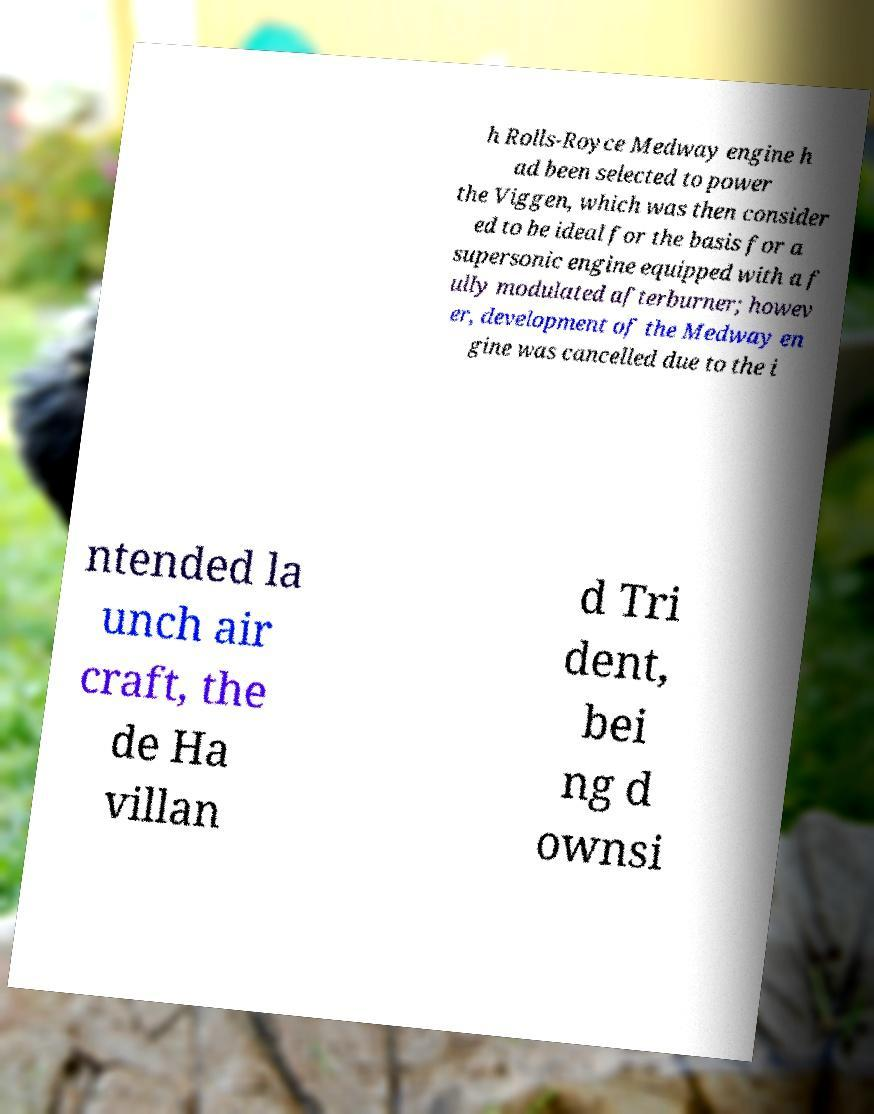Could you assist in decoding the text presented in this image and type it out clearly? h Rolls-Royce Medway engine h ad been selected to power the Viggen, which was then consider ed to be ideal for the basis for a supersonic engine equipped with a f ully modulated afterburner; howev er, development of the Medway en gine was cancelled due to the i ntended la unch air craft, the de Ha villan d Tri dent, bei ng d ownsi 